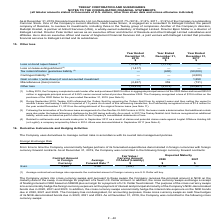According to Teekay Corporation's financial document, What was the Loss on lease extinguishment in 2019? According to the financial document, (1,417) (in thousands). The relevant text states: "Loss on lease extinguishment (2) (1,417) — —..." Also, What was the loss recognized by the company in December 2019? According to the financial document, $10.6 million. The relevant text states: "ue November 2022. The Company recognized a loss of $10.6 million on the purchase of the 2020 Notes for the year ended December 31, 2019 (see Note 9)...." Also, What was the loss on bond repurchases in 2019, 2018 and 2017 respectively? The document contains multiple relevant values: (10,601), (1,772), 0 (in thousands). From the document: "Loss on bond repurchases (1) (10,601) (1,772) — Loss on bond repurchases (1) (10,601) (1,772) — Loss on bond repurchases (1) (10,601) (1,772) —..." Also, can you calculate: What is the average Loss on lease extinguishment for 2017-2019? To answer this question, I need to perform calculations using the financial data. The calculation is: -(1,417 + 0 + 0) / 3, which equals -472.33 (in thousands). This is based on the information: "Loss on lease extinguishment (2) (1,417) — — Loss on lease extinguishment (2) (1,417) — —..." The key data points involved are: 0, 1,417. Additionally, In which year is the Gain on sale / (write-down) of cost-accounted investment less than 1,000 thousands? The document shows two values: 2019 and 2018. Locate and analyze gain on sale / (write-down) of cost-accounted investment in row 9. From the document: "As at December 31, 2019, Resolute Investments, Ltd. (or Resolute ) owned 31.7% (2018 – 31.8%, 2017 – 31.9%) of the Company’ ute Investments, Ltd. (or ..." Also, can you calculate: What is the change in Other loss from 2018 to 2019? Based on the calculation: -14,475 - (-2,013), the result is -12462 (in thousands). This is based on the information: "Other loss (14,475) (2,013) (53,981) Other loss (14,475) (2,013) (53,981)..." The key data points involved are: 14,475, 2,013. 